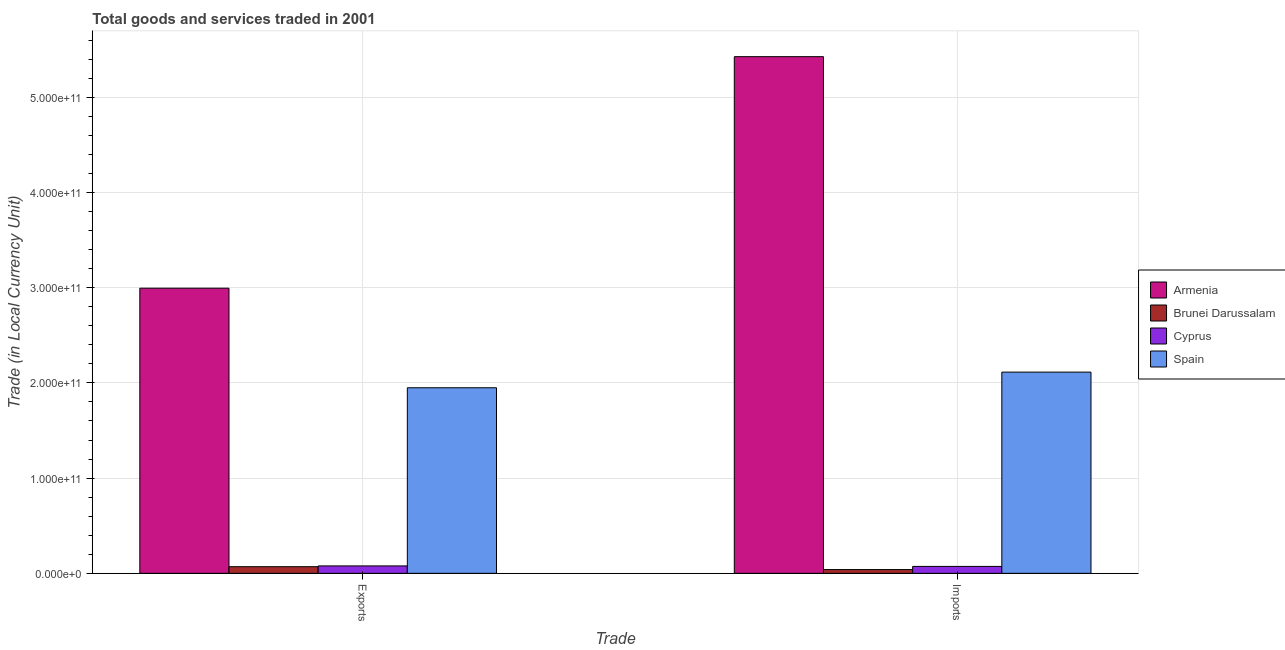Are the number of bars per tick equal to the number of legend labels?
Your answer should be very brief. Yes. What is the label of the 1st group of bars from the left?
Make the answer very short. Exports. What is the imports of goods and services in Cyprus?
Keep it short and to the point. 7.27e+09. Across all countries, what is the maximum export of goods and services?
Ensure brevity in your answer.  2.99e+11. Across all countries, what is the minimum imports of goods and services?
Offer a terse response. 3.93e+09. In which country was the export of goods and services maximum?
Offer a terse response. Armenia. In which country was the export of goods and services minimum?
Provide a short and direct response. Brunei Darussalam. What is the total export of goods and services in the graph?
Make the answer very short. 5.09e+11. What is the difference between the imports of goods and services in Cyprus and that in Armenia?
Your response must be concise. -5.35e+11. What is the difference between the imports of goods and services in Cyprus and the export of goods and services in Brunei Darussalam?
Offer a very short reply. 2.89e+08. What is the average export of goods and services per country?
Ensure brevity in your answer.  1.27e+11. What is the difference between the imports of goods and services and export of goods and services in Armenia?
Make the answer very short. 2.43e+11. In how many countries, is the export of goods and services greater than 80000000000 LCU?
Your response must be concise. 2. What is the ratio of the imports of goods and services in Cyprus to that in Armenia?
Make the answer very short. 0.01. What does the 2nd bar from the right in Exports represents?
Your response must be concise. Cyprus. How many countries are there in the graph?
Keep it short and to the point. 4. What is the difference between two consecutive major ticks on the Y-axis?
Keep it short and to the point. 1.00e+11. Are the values on the major ticks of Y-axis written in scientific E-notation?
Provide a succinct answer. Yes. Does the graph contain any zero values?
Your answer should be very brief. No. Does the graph contain grids?
Give a very brief answer. Yes. Where does the legend appear in the graph?
Your answer should be compact. Center right. What is the title of the graph?
Provide a short and direct response. Total goods and services traded in 2001. What is the label or title of the X-axis?
Give a very brief answer. Trade. What is the label or title of the Y-axis?
Offer a terse response. Trade (in Local Currency Unit). What is the Trade (in Local Currency Unit) of Armenia in Exports?
Your response must be concise. 2.99e+11. What is the Trade (in Local Currency Unit) in Brunei Darussalam in Exports?
Give a very brief answer. 6.98e+09. What is the Trade (in Local Currency Unit) in Cyprus in Exports?
Ensure brevity in your answer.  7.79e+09. What is the Trade (in Local Currency Unit) of Spain in Exports?
Provide a short and direct response. 1.95e+11. What is the Trade (in Local Currency Unit) of Armenia in Imports?
Make the answer very short. 5.43e+11. What is the Trade (in Local Currency Unit) in Brunei Darussalam in Imports?
Provide a short and direct response. 3.93e+09. What is the Trade (in Local Currency Unit) of Cyprus in Imports?
Your response must be concise. 7.27e+09. What is the Trade (in Local Currency Unit) in Spain in Imports?
Your answer should be very brief. 2.11e+11. Across all Trade, what is the maximum Trade (in Local Currency Unit) of Armenia?
Ensure brevity in your answer.  5.43e+11. Across all Trade, what is the maximum Trade (in Local Currency Unit) in Brunei Darussalam?
Offer a very short reply. 6.98e+09. Across all Trade, what is the maximum Trade (in Local Currency Unit) in Cyprus?
Your answer should be compact. 7.79e+09. Across all Trade, what is the maximum Trade (in Local Currency Unit) in Spain?
Ensure brevity in your answer.  2.11e+11. Across all Trade, what is the minimum Trade (in Local Currency Unit) of Armenia?
Keep it short and to the point. 2.99e+11. Across all Trade, what is the minimum Trade (in Local Currency Unit) in Brunei Darussalam?
Your answer should be very brief. 3.93e+09. Across all Trade, what is the minimum Trade (in Local Currency Unit) of Cyprus?
Offer a very short reply. 7.27e+09. Across all Trade, what is the minimum Trade (in Local Currency Unit) of Spain?
Make the answer very short. 1.95e+11. What is the total Trade (in Local Currency Unit) of Armenia in the graph?
Offer a terse response. 8.42e+11. What is the total Trade (in Local Currency Unit) of Brunei Darussalam in the graph?
Keep it short and to the point. 1.09e+1. What is the total Trade (in Local Currency Unit) in Cyprus in the graph?
Your answer should be compact. 1.51e+1. What is the total Trade (in Local Currency Unit) of Spain in the graph?
Your answer should be compact. 4.06e+11. What is the difference between the Trade (in Local Currency Unit) in Armenia in Exports and that in Imports?
Your answer should be compact. -2.43e+11. What is the difference between the Trade (in Local Currency Unit) of Brunei Darussalam in Exports and that in Imports?
Offer a terse response. 3.04e+09. What is the difference between the Trade (in Local Currency Unit) of Cyprus in Exports and that in Imports?
Provide a short and direct response. 5.22e+08. What is the difference between the Trade (in Local Currency Unit) in Spain in Exports and that in Imports?
Ensure brevity in your answer.  -1.64e+1. What is the difference between the Trade (in Local Currency Unit) of Armenia in Exports and the Trade (in Local Currency Unit) of Brunei Darussalam in Imports?
Your answer should be very brief. 2.96e+11. What is the difference between the Trade (in Local Currency Unit) in Armenia in Exports and the Trade (in Local Currency Unit) in Cyprus in Imports?
Your response must be concise. 2.92e+11. What is the difference between the Trade (in Local Currency Unit) of Armenia in Exports and the Trade (in Local Currency Unit) of Spain in Imports?
Keep it short and to the point. 8.81e+1. What is the difference between the Trade (in Local Currency Unit) of Brunei Darussalam in Exports and the Trade (in Local Currency Unit) of Cyprus in Imports?
Keep it short and to the point. -2.89e+08. What is the difference between the Trade (in Local Currency Unit) in Brunei Darussalam in Exports and the Trade (in Local Currency Unit) in Spain in Imports?
Your answer should be compact. -2.04e+11. What is the difference between the Trade (in Local Currency Unit) in Cyprus in Exports and the Trade (in Local Currency Unit) in Spain in Imports?
Provide a succinct answer. -2.04e+11. What is the average Trade (in Local Currency Unit) in Armenia per Trade?
Offer a terse response. 4.21e+11. What is the average Trade (in Local Currency Unit) in Brunei Darussalam per Trade?
Ensure brevity in your answer.  5.46e+09. What is the average Trade (in Local Currency Unit) of Cyprus per Trade?
Provide a short and direct response. 7.53e+09. What is the average Trade (in Local Currency Unit) in Spain per Trade?
Offer a terse response. 2.03e+11. What is the difference between the Trade (in Local Currency Unit) in Armenia and Trade (in Local Currency Unit) in Brunei Darussalam in Exports?
Offer a very short reply. 2.92e+11. What is the difference between the Trade (in Local Currency Unit) of Armenia and Trade (in Local Currency Unit) of Cyprus in Exports?
Provide a short and direct response. 2.92e+11. What is the difference between the Trade (in Local Currency Unit) of Armenia and Trade (in Local Currency Unit) of Spain in Exports?
Your response must be concise. 1.05e+11. What is the difference between the Trade (in Local Currency Unit) in Brunei Darussalam and Trade (in Local Currency Unit) in Cyprus in Exports?
Your answer should be very brief. -8.10e+08. What is the difference between the Trade (in Local Currency Unit) of Brunei Darussalam and Trade (in Local Currency Unit) of Spain in Exports?
Offer a terse response. -1.88e+11. What is the difference between the Trade (in Local Currency Unit) in Cyprus and Trade (in Local Currency Unit) in Spain in Exports?
Make the answer very short. -1.87e+11. What is the difference between the Trade (in Local Currency Unit) of Armenia and Trade (in Local Currency Unit) of Brunei Darussalam in Imports?
Your answer should be very brief. 5.39e+11. What is the difference between the Trade (in Local Currency Unit) of Armenia and Trade (in Local Currency Unit) of Cyprus in Imports?
Provide a succinct answer. 5.35e+11. What is the difference between the Trade (in Local Currency Unit) in Armenia and Trade (in Local Currency Unit) in Spain in Imports?
Provide a short and direct response. 3.31e+11. What is the difference between the Trade (in Local Currency Unit) in Brunei Darussalam and Trade (in Local Currency Unit) in Cyprus in Imports?
Keep it short and to the point. -3.33e+09. What is the difference between the Trade (in Local Currency Unit) in Brunei Darussalam and Trade (in Local Currency Unit) in Spain in Imports?
Your answer should be compact. -2.07e+11. What is the difference between the Trade (in Local Currency Unit) in Cyprus and Trade (in Local Currency Unit) in Spain in Imports?
Provide a succinct answer. -2.04e+11. What is the ratio of the Trade (in Local Currency Unit) of Armenia in Exports to that in Imports?
Ensure brevity in your answer.  0.55. What is the ratio of the Trade (in Local Currency Unit) in Brunei Darussalam in Exports to that in Imports?
Make the answer very short. 1.77. What is the ratio of the Trade (in Local Currency Unit) in Cyprus in Exports to that in Imports?
Make the answer very short. 1.07. What is the ratio of the Trade (in Local Currency Unit) of Spain in Exports to that in Imports?
Your response must be concise. 0.92. What is the difference between the highest and the second highest Trade (in Local Currency Unit) of Armenia?
Your answer should be very brief. 2.43e+11. What is the difference between the highest and the second highest Trade (in Local Currency Unit) of Brunei Darussalam?
Ensure brevity in your answer.  3.04e+09. What is the difference between the highest and the second highest Trade (in Local Currency Unit) of Cyprus?
Ensure brevity in your answer.  5.22e+08. What is the difference between the highest and the second highest Trade (in Local Currency Unit) of Spain?
Your response must be concise. 1.64e+1. What is the difference between the highest and the lowest Trade (in Local Currency Unit) of Armenia?
Offer a terse response. 2.43e+11. What is the difference between the highest and the lowest Trade (in Local Currency Unit) in Brunei Darussalam?
Provide a succinct answer. 3.04e+09. What is the difference between the highest and the lowest Trade (in Local Currency Unit) in Cyprus?
Provide a short and direct response. 5.22e+08. What is the difference between the highest and the lowest Trade (in Local Currency Unit) of Spain?
Your response must be concise. 1.64e+1. 